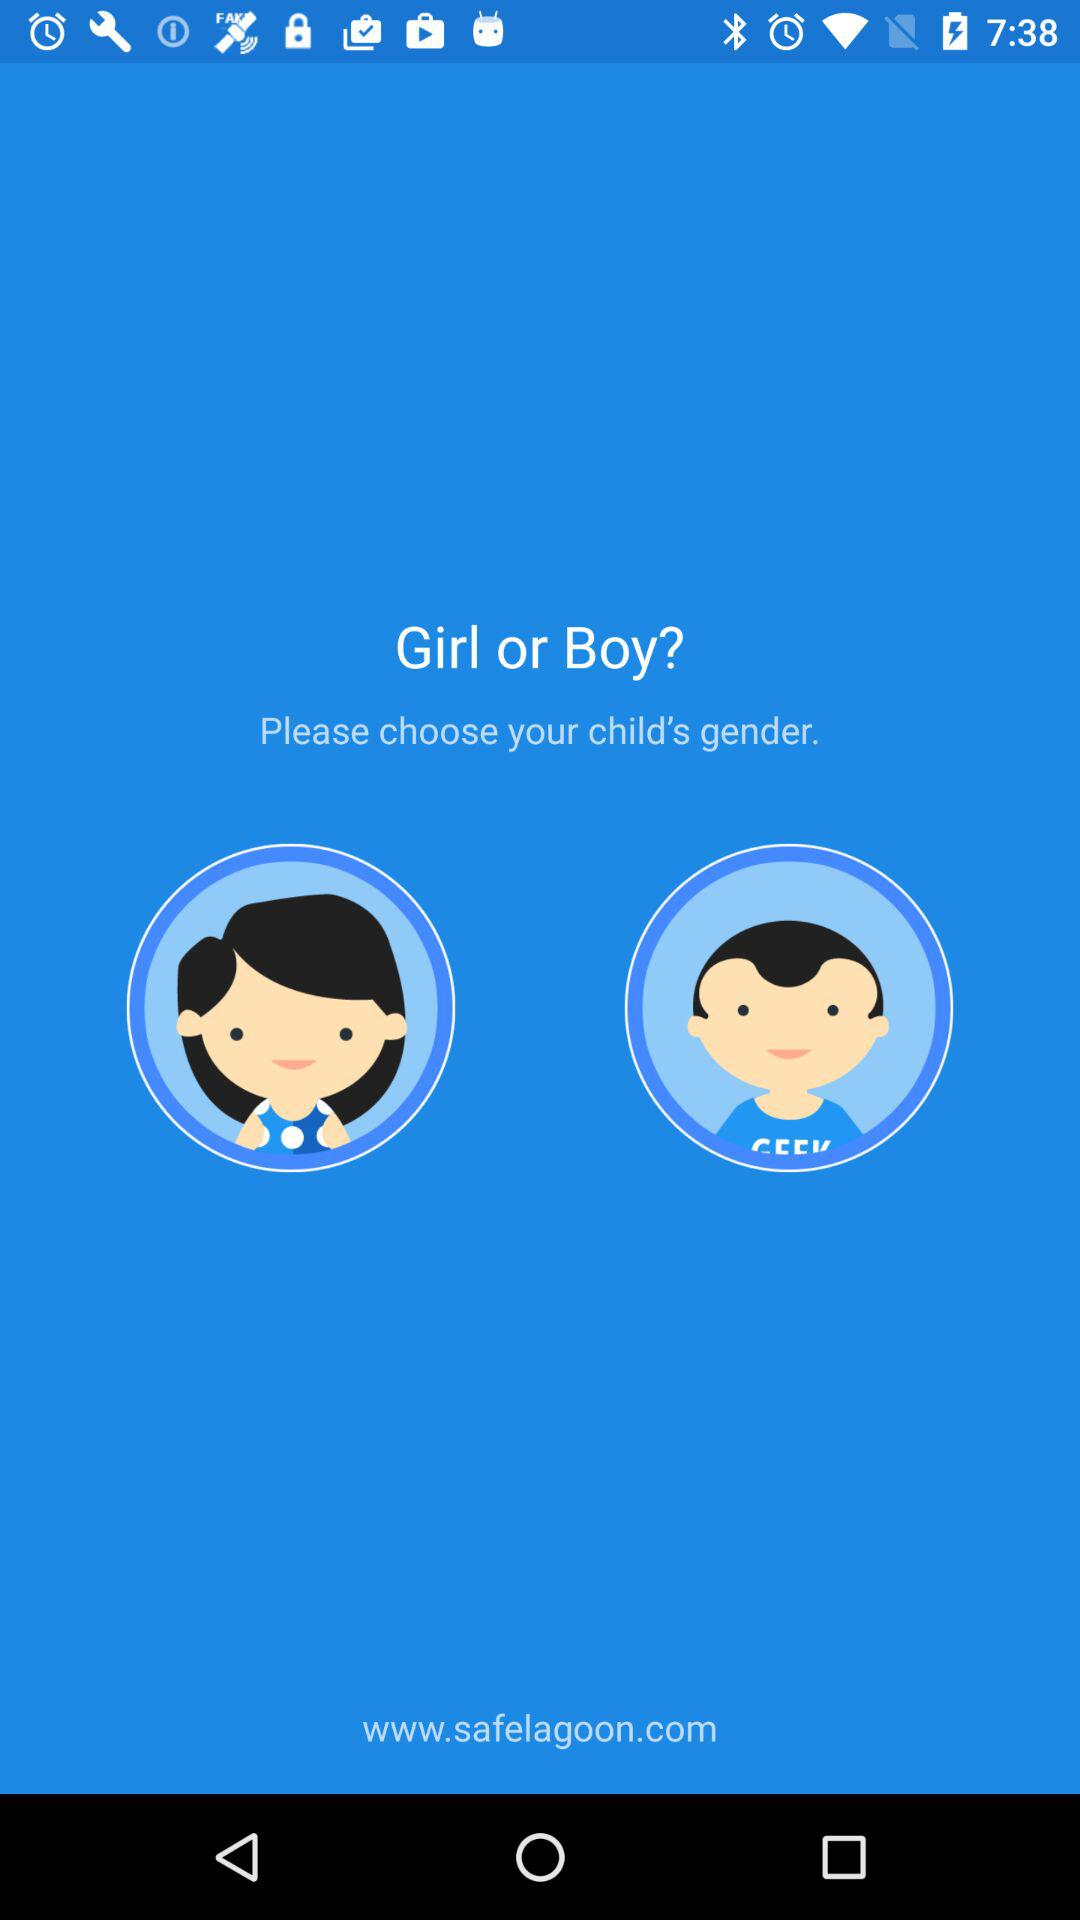What is the gender option? The gender options are "Girl" and "Boy". 